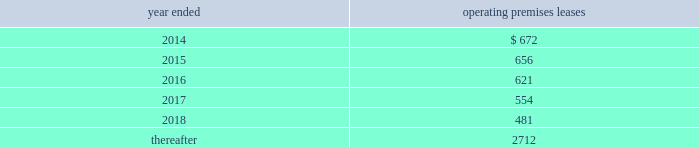Morgan stanley notes to consolidated financial statements 2014 ( continued ) lending commitments .
Primary lending commitments are those that are originated by the company whereas secondary lending commitments are purchased from third parties in the market .
The commitments include lending commitments that are made to investment grade and non-investment grade companies in connection with corporate lending and other business activities .
Commitments for secured lending transactions .
Secured lending commitments are extended by the company to companies and are secured by real estate or other physical assets of the borrower .
Loans made under these arrangements typically are at variable rates and generally provide for over-collateralization based upon the creditworthiness of the borrower .
Forward starting reverse repurchase agreements .
The company has entered into forward starting securities purchased under agreements to resell ( agreements that have a trade date at or prior to december 31 , 2013 and settle subsequent to period-end ) that are primarily secured by collateral from u.s .
Government agency securities and other sovereign government obligations .
Commercial and residential mortgage-related commitments .
The company enters into forward purchase contracts involving residential mortgage loans , residential mortgage lending commitments to individuals and residential home equity lines of credit .
In addition , the company enters into commitments to originate commercial and residential mortgage loans .
Underwriting commitments .
The company provides underwriting commitments in connection with its capital raising sources to a diverse group of corporate and other institutional clients .
Other lending commitments .
Other commitments generally include commercial lending commitments to small businesses and commitments related to securities-based lending activities in connection with the company 2019s wealth management business segment .
The company sponsors several non-consolidated investment funds for third-party investors where the company typically acts as general partner of , and investment advisor to , these funds and typically commits to invest a minority of the capital of such funds , with subscribing third-party investors contributing the majority .
The company 2019s employees , including its senior officers , as well as the company 2019s directors , may participate on the same terms and conditions as other investors in certain of these funds that the company forms primarily for client investment , except that the company may waive or lower applicable fees and charges for its employees .
The company has contractual capital commitments , guarantees , lending facilities and counterparty arrangements with respect to these investment funds .
Premises and equipment .
The company has non-cancelable operating leases covering premises and equipment ( excluding commodities operating leases , shown separately ) .
At december 31 , 2013 , future minimum rental commitments under such leases ( net of subleases , principally on office rentals ) were as follows ( dollars in millions ) : year ended operating premises leases .

What is the average operating lease liability for 2014-2016? 
Computations: (((672 + 656) + 621) / 3)
Answer: 649.66667. 